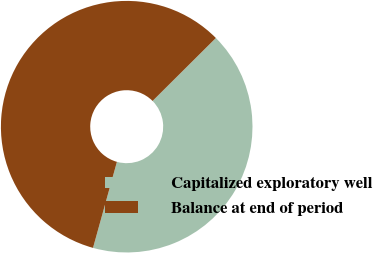<chart> <loc_0><loc_0><loc_500><loc_500><pie_chart><fcel>Capitalized exploratory well<fcel>Balance at end of period<nl><fcel>41.77%<fcel>58.23%<nl></chart> 